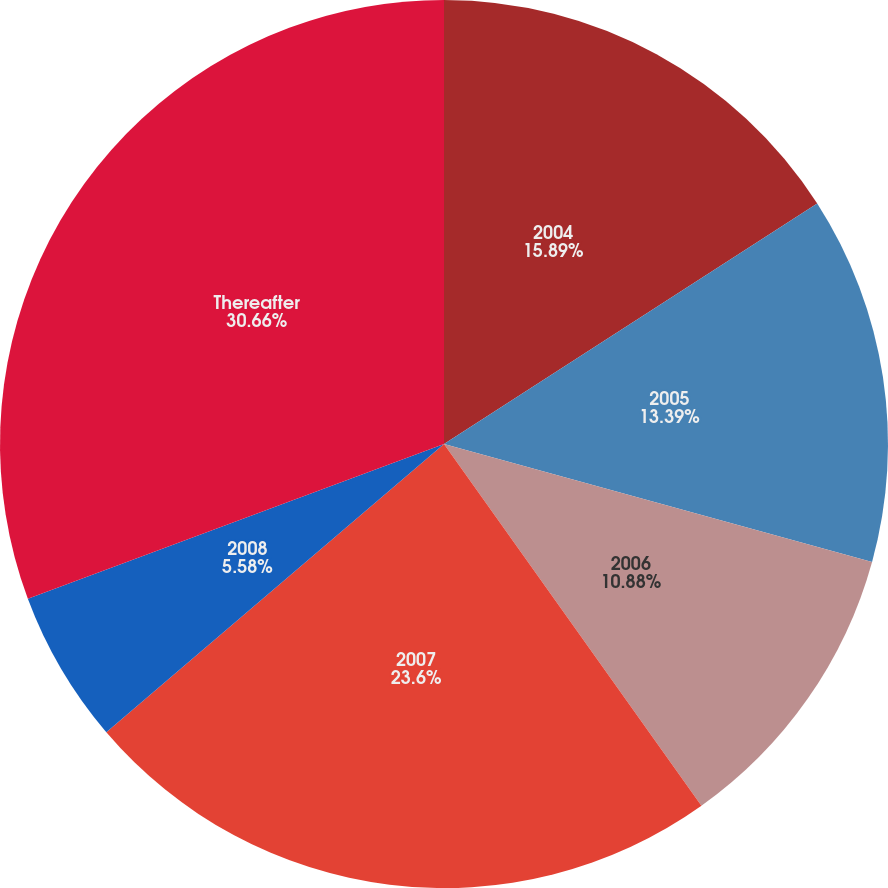Convert chart to OTSL. <chart><loc_0><loc_0><loc_500><loc_500><pie_chart><fcel>2004<fcel>2005<fcel>2006<fcel>2007<fcel>2008<fcel>Thereafter<nl><fcel>15.89%<fcel>13.39%<fcel>10.88%<fcel>23.6%<fcel>5.58%<fcel>30.67%<nl></chart> 